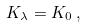<formula> <loc_0><loc_0><loc_500><loc_500>K _ { \lambda } = K _ { 0 } \, ,</formula> 